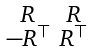Convert formula to latex. <formula><loc_0><loc_0><loc_500><loc_500>\begin{smallmatrix} R & R \\ - R ^ { \top } & R ^ { \top } \end{smallmatrix}</formula> 